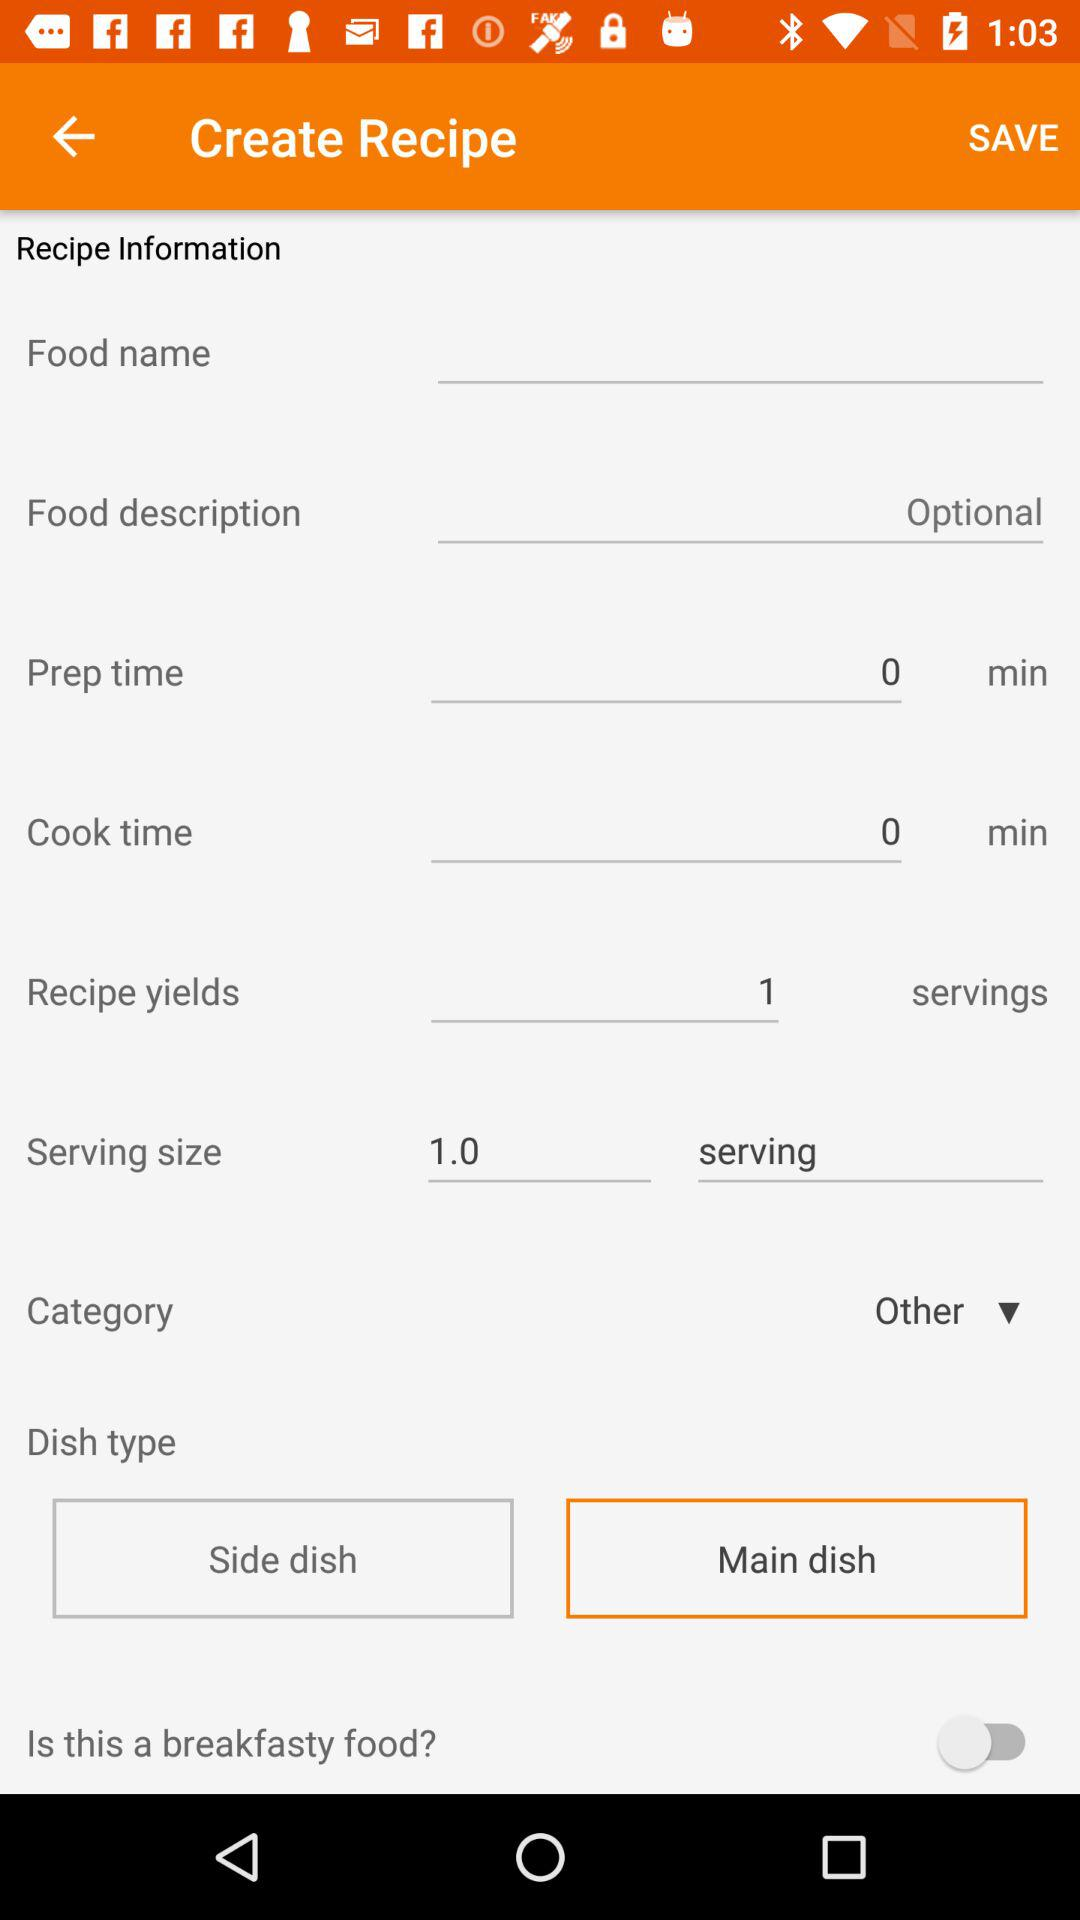What is the serving size? The serving size is only 1. 